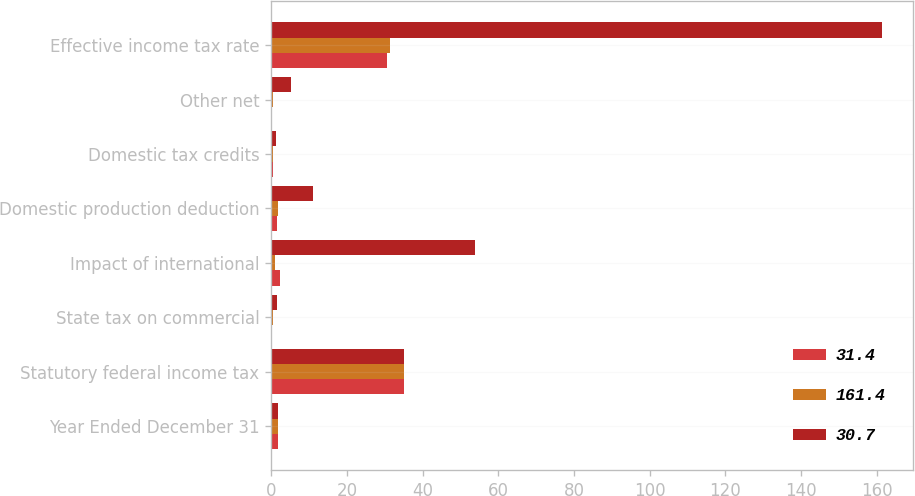Convert chart to OTSL. <chart><loc_0><loc_0><loc_500><loc_500><stacked_bar_chart><ecel><fcel>Year Ended December 31<fcel>Statutory federal income tax<fcel>State tax on commercial<fcel>Impact of international<fcel>Domestic production deduction<fcel>Domestic tax credits<fcel>Other net<fcel>Effective income tax rate<nl><fcel>31.4<fcel>1.8<fcel>35<fcel>0.2<fcel>2.4<fcel>1.6<fcel>0.6<fcel>0.1<fcel>30.7<nl><fcel>161.4<fcel>1.8<fcel>35<fcel>0.4<fcel>1<fcel>1.8<fcel>0.6<fcel>0.6<fcel>31.4<nl><fcel>30.7<fcel>1.8<fcel>35<fcel>1.6<fcel>53.8<fcel>11.2<fcel>1.4<fcel>5.3<fcel>161.4<nl></chart> 